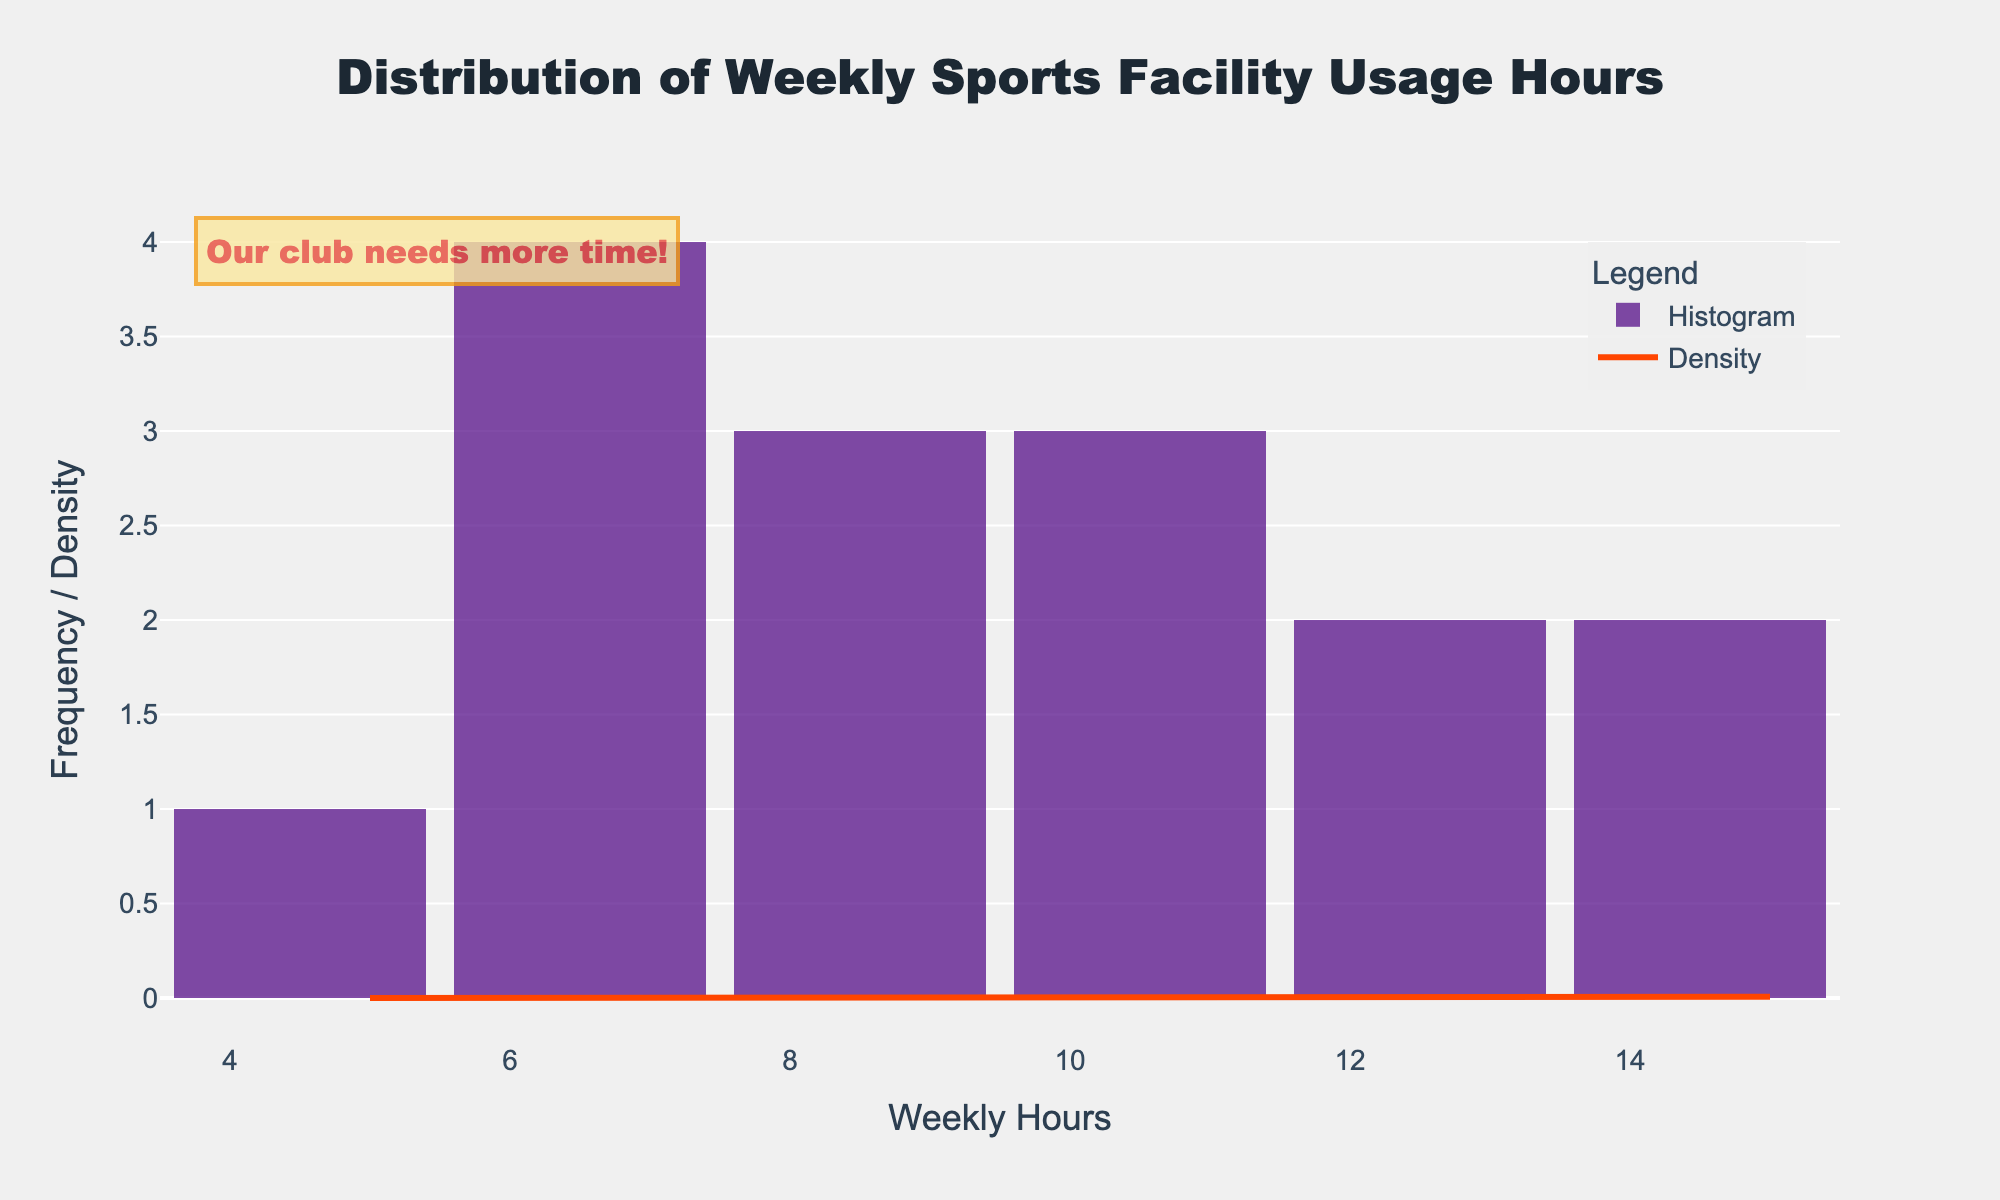What does the title of the figure say? The title is displayed at the top of the figure in larger and bold text. Based on the given code, the title reads "Distribution of Weekly Sports Facility Usage Hours".
Answer: Distribution of Weekly Sports Facility Usage Hours What is the range of weekly hours used by the clubs? By observing the x-axis, the range of weekly hours used across different clubs is from the minimum to the maximum value indicated. The histogram spread and x-axis ticks range from 5 to 15 hours.
Answer: 5 to 15 hours Which club recorded the lowest weekly sports facility usage hours and how many hours did they use? The histogram shows bars corresponding to the lowest value along the x-axis. The data indicates that Birchwood Table Tennis Club has the lowest usage, which is 5 hours per week.
Answer: Birchwood Table Tennis Club, 5 hours How many clubs use the sports facility for more than 10 hours a week? Observing the histogram, we count the bars that exceed the 10-hour mark on the x-axis. The clubs are Riverside Football Club, Sunnybrook Swimming Club, Lakeview Hockey Club, Maple Leaf Gymnastics, and Elmwood Athletics Club, totaling 5 clubs.
Answer: 5 clubs Which club recorded the highest weekly sports facility usage hours and how many hours did they use? Reviewing the histogram and cross-referencing with provided data, Sunnybrook Swimming Club recorded the highest usage at 15 hours per week.
Answer: Sunnybrook Swimming Club, 15 hours What is the approximate peak value (highest point) of the KDE curve? The KDE curve peaks can visually be estimated by observing its highest point on the y-axis. Estimating from the figure, the highest point seems to be around the usage range of 7 to 9 hours.
Answer: Around 7 to 9 hours How many clubs use the sports facility exactly 8 hours a week? Referring to the histogram, we find the bar directly above the 8-hour mark on the x-axis. It indicates 2 clubs which are Oakdale Tennis Association and Cedar Park Rugby Team.
Answer: 2 clubs Based on the data, what is the median weekly sports facility usage hours? Ordering the usage hours values from lowest to highest: 5, 6, 6, 7, 7, 8, 8, 9, 10, 10, 11, 12, 13, 14, 15. The median value, being the middle number in a sorted list of 15 data points, is 9 hours.
Answer: 9 hours By looking at the histogram, do more clubs tend to use the sports facility for fewer or more than 10 hours a week? Observing the frequency of bars split by the 10-hour mark on the x-axis in the histogram, there are more clubs with bars to the left (under 10 hours) than to the right (over 10 hours).
Answer: Fewer than 10 hours What does the annotation "Our club needs more time!" imply in the context of the figure? This annotation suggests that the person or club lobbying for time is likely falling below the median or lower-end usage hours, indicating a need for more facility access compared to others.
Answer: They need more facility time 